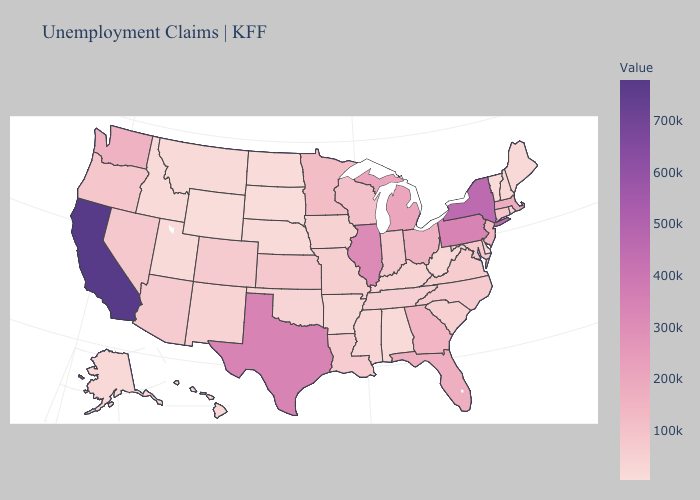Does Indiana have the highest value in the MidWest?
Concise answer only. No. Does Connecticut have the lowest value in the USA?
Write a very short answer. No. Among the states that border Massachusetts , which have the highest value?
Concise answer only. New York. Does South Carolina have the lowest value in the South?
Give a very brief answer. No. Does Utah have the lowest value in the USA?
Short answer required. No. 